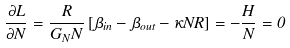Convert formula to latex. <formula><loc_0><loc_0><loc_500><loc_500>\frac { \partial L } { \partial N } = \frac { R } { G _ { N } N } \left [ \beta _ { i n } - \beta _ { o u t } - \kappa N R \right ] = - \frac { H } { N } = 0</formula> 